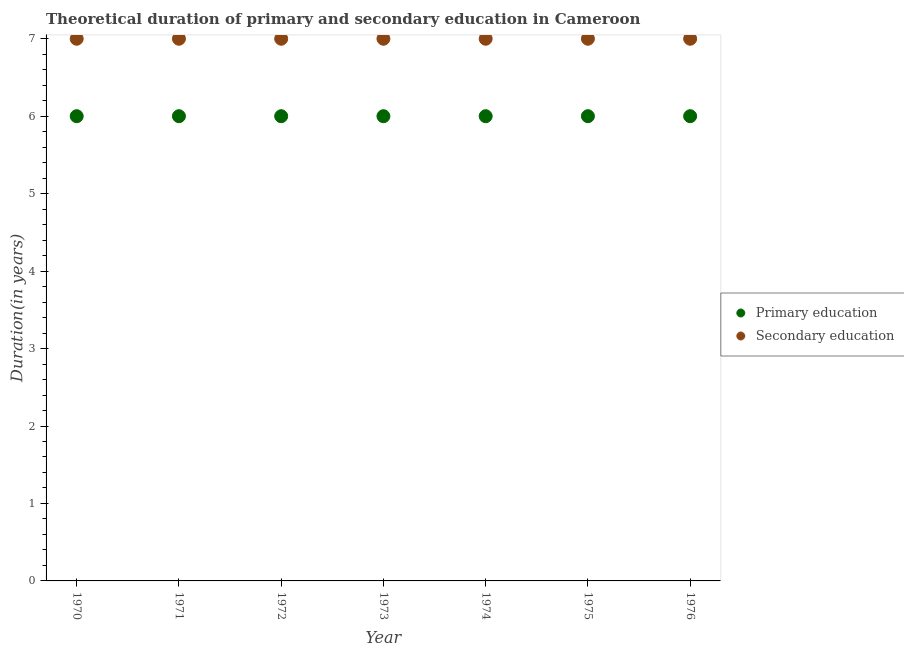What is the duration of primary education in 1976?
Offer a very short reply. 6. Across all years, what is the maximum duration of secondary education?
Make the answer very short. 7. In which year was the duration of secondary education maximum?
Your answer should be very brief. 1970. What is the total duration of primary education in the graph?
Your answer should be compact. 42. What is the difference between the duration of primary education in 1973 and the duration of secondary education in 1971?
Provide a succinct answer. -1. What is the average duration of secondary education per year?
Provide a succinct answer. 7. In the year 1975, what is the difference between the duration of secondary education and duration of primary education?
Make the answer very short. 1. What is the ratio of the duration of secondary education in 1971 to that in 1973?
Keep it short and to the point. 1. Is the duration of primary education in 1974 less than that in 1975?
Ensure brevity in your answer.  No. Is the difference between the duration of primary education in 1971 and 1973 greater than the difference between the duration of secondary education in 1971 and 1973?
Your response must be concise. No. What is the difference between the highest and the second highest duration of secondary education?
Offer a terse response. 0. In how many years, is the duration of secondary education greater than the average duration of secondary education taken over all years?
Your answer should be very brief. 0. Is the sum of the duration of primary education in 1974 and 1975 greater than the maximum duration of secondary education across all years?
Make the answer very short. Yes. Does the duration of secondary education monotonically increase over the years?
Provide a succinct answer. No. Is the duration of secondary education strictly less than the duration of primary education over the years?
Ensure brevity in your answer.  No. Does the graph contain any zero values?
Provide a succinct answer. No. How many legend labels are there?
Provide a succinct answer. 2. What is the title of the graph?
Provide a succinct answer. Theoretical duration of primary and secondary education in Cameroon. Does "From human activities" appear as one of the legend labels in the graph?
Provide a short and direct response. No. What is the label or title of the Y-axis?
Your answer should be compact. Duration(in years). What is the Duration(in years) of Primary education in 1970?
Give a very brief answer. 6. What is the Duration(in years) in Primary education in 1971?
Give a very brief answer. 6. What is the Duration(in years) in Secondary education in 1971?
Your response must be concise. 7. What is the Duration(in years) of Primary education in 1972?
Your answer should be compact. 6. What is the Duration(in years) in Primary education in 1973?
Ensure brevity in your answer.  6. What is the Duration(in years) in Primary education in 1974?
Give a very brief answer. 6. What is the Duration(in years) of Secondary education in 1974?
Provide a short and direct response. 7. What is the Duration(in years) in Secondary education in 1975?
Your answer should be very brief. 7. Across all years, what is the maximum Duration(in years) in Primary education?
Offer a terse response. 6. Across all years, what is the maximum Duration(in years) of Secondary education?
Your answer should be very brief. 7. Across all years, what is the minimum Duration(in years) in Primary education?
Your answer should be compact. 6. Across all years, what is the minimum Duration(in years) of Secondary education?
Your answer should be very brief. 7. What is the total Duration(in years) of Secondary education in the graph?
Your answer should be compact. 49. What is the difference between the Duration(in years) in Primary education in 1970 and that in 1971?
Provide a succinct answer. 0. What is the difference between the Duration(in years) in Primary education in 1970 and that in 1973?
Your answer should be compact. 0. What is the difference between the Duration(in years) in Secondary education in 1970 and that in 1975?
Provide a succinct answer. 0. What is the difference between the Duration(in years) in Primary education in 1971 and that in 1973?
Ensure brevity in your answer.  0. What is the difference between the Duration(in years) in Secondary education in 1971 and that in 1973?
Keep it short and to the point. 0. What is the difference between the Duration(in years) in Secondary education in 1971 and that in 1974?
Keep it short and to the point. 0. What is the difference between the Duration(in years) of Primary education in 1972 and that in 1974?
Offer a terse response. 0. What is the difference between the Duration(in years) of Primary education in 1972 and that in 1976?
Offer a very short reply. 0. What is the difference between the Duration(in years) in Primary education in 1973 and that in 1974?
Offer a terse response. 0. What is the difference between the Duration(in years) of Secondary education in 1973 and that in 1974?
Give a very brief answer. 0. What is the difference between the Duration(in years) of Primary education in 1973 and that in 1975?
Make the answer very short. 0. What is the difference between the Duration(in years) in Secondary education in 1973 and that in 1975?
Offer a terse response. 0. What is the difference between the Duration(in years) of Primary education in 1973 and that in 1976?
Provide a short and direct response. 0. What is the difference between the Duration(in years) of Primary education in 1975 and that in 1976?
Provide a short and direct response. 0. What is the difference between the Duration(in years) in Primary education in 1970 and the Duration(in years) in Secondary education in 1973?
Offer a terse response. -1. What is the difference between the Duration(in years) of Primary education in 1970 and the Duration(in years) of Secondary education in 1975?
Your response must be concise. -1. What is the difference between the Duration(in years) of Primary education in 1970 and the Duration(in years) of Secondary education in 1976?
Your answer should be compact. -1. What is the difference between the Duration(in years) in Primary education in 1971 and the Duration(in years) in Secondary education in 1973?
Provide a short and direct response. -1. What is the difference between the Duration(in years) in Primary education in 1971 and the Duration(in years) in Secondary education in 1974?
Make the answer very short. -1. What is the difference between the Duration(in years) in Primary education in 1972 and the Duration(in years) in Secondary education in 1974?
Ensure brevity in your answer.  -1. What is the difference between the Duration(in years) in Primary education in 1972 and the Duration(in years) in Secondary education in 1975?
Your response must be concise. -1. What is the difference between the Duration(in years) in Primary education in 1972 and the Duration(in years) in Secondary education in 1976?
Offer a very short reply. -1. What is the difference between the Duration(in years) of Primary education in 1973 and the Duration(in years) of Secondary education in 1976?
Provide a short and direct response. -1. What is the difference between the Duration(in years) in Primary education in 1974 and the Duration(in years) in Secondary education in 1975?
Make the answer very short. -1. What is the average Duration(in years) of Secondary education per year?
Provide a short and direct response. 7. In the year 1970, what is the difference between the Duration(in years) in Primary education and Duration(in years) in Secondary education?
Ensure brevity in your answer.  -1. In the year 1976, what is the difference between the Duration(in years) of Primary education and Duration(in years) of Secondary education?
Your response must be concise. -1. What is the ratio of the Duration(in years) of Secondary education in 1970 to that in 1971?
Keep it short and to the point. 1. What is the ratio of the Duration(in years) of Primary education in 1970 to that in 1972?
Keep it short and to the point. 1. What is the ratio of the Duration(in years) in Secondary education in 1970 to that in 1972?
Provide a succinct answer. 1. What is the ratio of the Duration(in years) in Secondary education in 1970 to that in 1973?
Your answer should be very brief. 1. What is the ratio of the Duration(in years) in Primary education in 1970 to that in 1974?
Keep it short and to the point. 1. What is the ratio of the Duration(in years) in Secondary education in 1970 to that in 1976?
Provide a succinct answer. 1. What is the ratio of the Duration(in years) in Secondary education in 1971 to that in 1972?
Make the answer very short. 1. What is the ratio of the Duration(in years) in Secondary education in 1971 to that in 1973?
Make the answer very short. 1. What is the ratio of the Duration(in years) in Primary education in 1971 to that in 1974?
Provide a short and direct response. 1. What is the ratio of the Duration(in years) in Secondary education in 1971 to that in 1974?
Provide a short and direct response. 1. What is the ratio of the Duration(in years) of Primary education in 1971 to that in 1975?
Provide a short and direct response. 1. What is the ratio of the Duration(in years) in Primary education in 1971 to that in 1976?
Provide a short and direct response. 1. What is the ratio of the Duration(in years) of Secondary education in 1971 to that in 1976?
Ensure brevity in your answer.  1. What is the ratio of the Duration(in years) of Primary education in 1972 to that in 1974?
Your answer should be compact. 1. What is the ratio of the Duration(in years) in Secondary education in 1972 to that in 1974?
Offer a terse response. 1. What is the ratio of the Duration(in years) in Primary education in 1972 to that in 1975?
Make the answer very short. 1. What is the ratio of the Duration(in years) of Secondary education in 1972 to that in 1976?
Give a very brief answer. 1. What is the ratio of the Duration(in years) in Secondary education in 1973 to that in 1974?
Offer a terse response. 1. What is the ratio of the Duration(in years) in Primary education in 1973 to that in 1975?
Give a very brief answer. 1. What is the ratio of the Duration(in years) in Secondary education in 1973 to that in 1975?
Keep it short and to the point. 1. What is the ratio of the Duration(in years) in Primary education in 1973 to that in 1976?
Give a very brief answer. 1. What is the ratio of the Duration(in years) of Primary education in 1974 to that in 1975?
Your answer should be compact. 1. What is the ratio of the Duration(in years) in Secondary education in 1974 to that in 1975?
Your response must be concise. 1. What is the ratio of the Duration(in years) in Primary education in 1974 to that in 1976?
Ensure brevity in your answer.  1. What is the ratio of the Duration(in years) of Secondary education in 1974 to that in 1976?
Provide a succinct answer. 1. What is the ratio of the Duration(in years) in Primary education in 1975 to that in 1976?
Your answer should be compact. 1. What is the difference between the highest and the lowest Duration(in years) in Primary education?
Offer a very short reply. 0. What is the difference between the highest and the lowest Duration(in years) of Secondary education?
Your response must be concise. 0. 